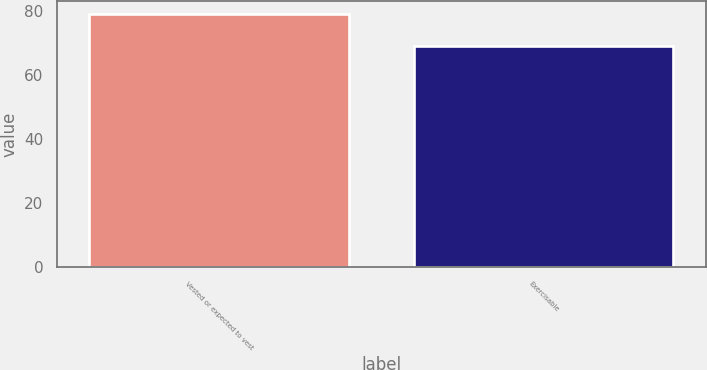<chart> <loc_0><loc_0><loc_500><loc_500><bar_chart><fcel>Vested or expected to vest<fcel>Exercisable<nl><fcel>79<fcel>69<nl></chart> 